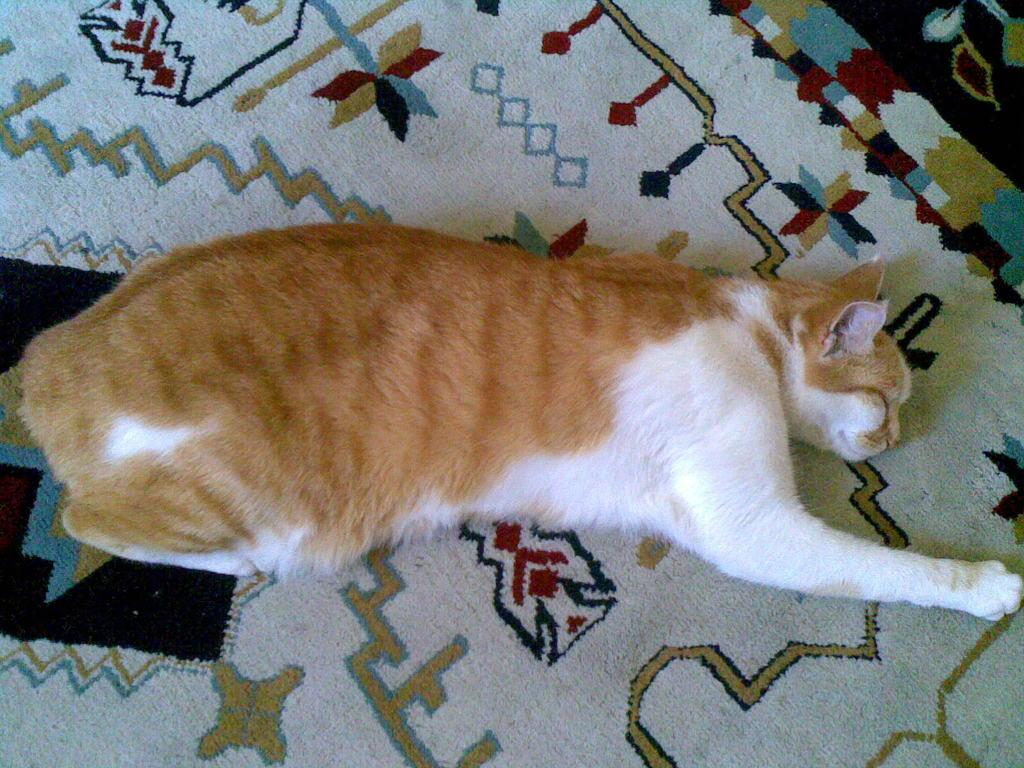What type of animal is present in the image? There is a cat in the image. What is the cat doing in the image? The cat is sleeping. On what surface is the cat resting in the image? The cat is on a surface that resembles a carpet. What type of degree does the cat have in the image? There is no indication in the image that the cat has a degree, as cats do not obtain degrees. 